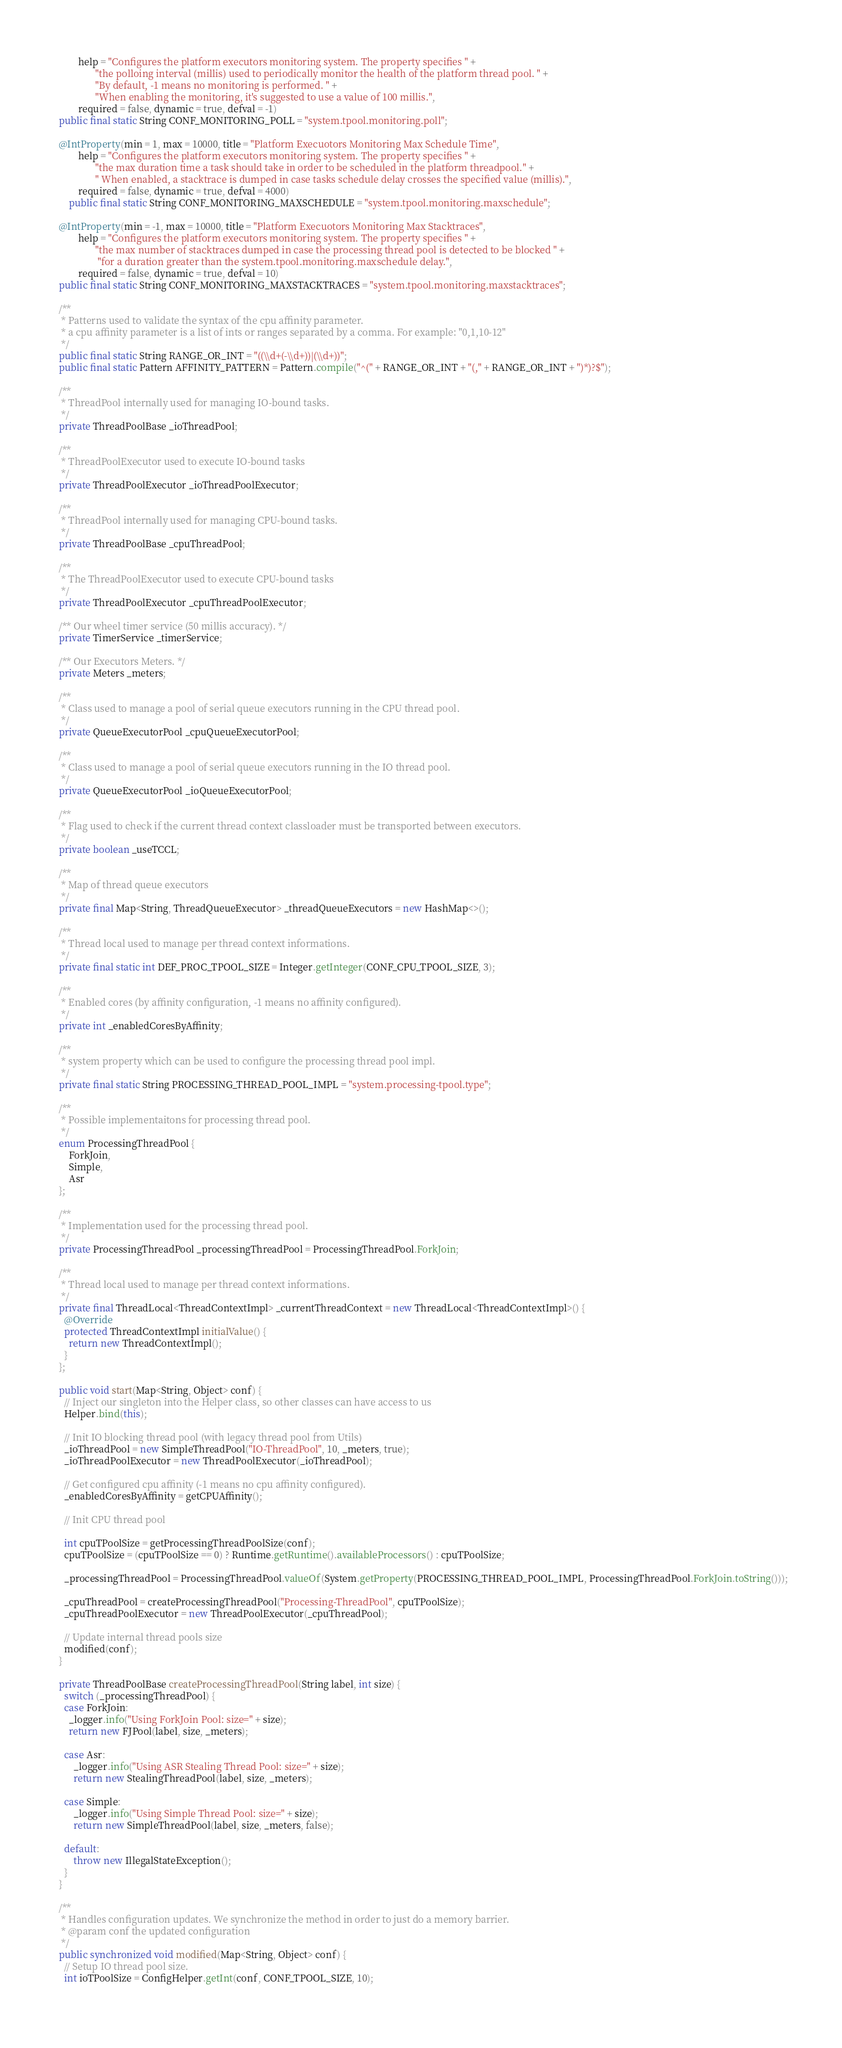Convert code to text. <code><loc_0><loc_0><loc_500><loc_500><_Java_>	      help = "Configures the platform executors monitoring system. The property specifies " +
	             "the polloing interval (millis) used to periodically monitor the health of the platform thread pool. " +
	    		 "By default, -1 means no monitoring is performed. " +
	             "When enabling the monitoring, it's suggested to use a value of 100 millis.",
	      required = false, dynamic = true, defval = -1)
  public final static String CONF_MONITORING_POLL = "system.tpool.monitoring.poll";

  @IntProperty(min = 1, max = 10000, title = "Platform Execuotors Monitoring Max Schedule Time",
	      help = "Configures the platform executors monitoring system. The property specifies " +
	             "the max duration time a task should take in order to be scheduled in the platform threadpool." +
	    		 " When enabled, a stacktrace is dumped in case tasks schedule delay crosses the specified value (millis).",
	      required = false, dynamic = true, defval = 4000)
	  public final static String CONF_MONITORING_MAXSCHEDULE = "system.tpool.monitoring.maxschedule";

  @IntProperty(min = -1, max = 10000, title = "Platform Execuotors Monitoring Max Stacktraces",
	      help = "Configures the platform executors monitoring system. The property specifies " +
	             "the max number of stacktraces dumped in case the processing thread pool is detected to be blocked " +
	    		  "for a duration greater than the system.tpool.monitoring.maxschedule delay.",
	      required = false, dynamic = true, defval = 10)
  public final static String CONF_MONITORING_MAXSTACKTRACES = "system.tpool.monitoring.maxstacktraces";

  /** 
   * Patterns used to validate the syntax of the cpu affinity parameter. 
   * a cpu affinity parameter is a list of ints or ranges separated by a comma. For example: "0,1,10-12"
   */
  public final static String RANGE_OR_INT = "((\\d+(-\\d+))|(\\d+))";
  public final static Pattern AFFINITY_PATTERN = Pattern.compile("^(" + RANGE_OR_INT + "(," + RANGE_OR_INT + ")*)?$");

  /** 
   * ThreadPool internally used for managing IO-bound tasks.
   */
  private ThreadPoolBase _ioThreadPool;
  
  /** 
   * ThreadPoolExecutor used to execute IO-bound tasks 
   */
  private ThreadPoolExecutor _ioThreadPoolExecutor;
  
  /** 
   * ThreadPool internally used for managing CPU-bound tasks.
   */
  private ThreadPoolBase _cpuThreadPool;
  
  /** 
   * The ThreadPoolExecutor used to execute CPU-bound tasks 
   */
  private ThreadPoolExecutor _cpuThreadPoolExecutor;
  
  /** Our wheel timer service (50 millis accuracy). */
  private TimerService _timerService;
    
  /** Our Executors Meters. */
  private Meters _meters;

  /** 
   * Class used to manage a pool of serial queue executors running in the CPU thread pool. 
   */
  private QueueExecutorPool _cpuQueueExecutorPool;
  
  /** 
   * Class used to manage a pool of serial queue executors running in the IO thread pool. 
   */
  private QueueExecutorPool _ioQueueExecutorPool;
  
  /** 
   * Flag used to check if the current thread context classloader must be transported between executors. 
   */
  private boolean _useTCCL;
  
  /** 
   * Map of thread queue executors 
   */
  private final Map<String, ThreadQueueExecutor> _threadQueueExecutors = new HashMap<>();
  
  /**
   * Thread local used to manage per thread context informations.
   */
  private final static int DEF_PROC_TPOOL_SIZE = Integer.getInteger(CONF_CPU_TPOOL_SIZE, 3);
  
  /**
   * Enabled cores (by affinity configuration, -1 means no affinity configured).
   */
  private int _enabledCoresByAffinity;
  
  /**
   * system property which can be used to configure the processing thread pool impl.
   */
  private final static String PROCESSING_THREAD_POOL_IMPL = "system.processing-tpool.type";
  
  /**
   * Possible implementaitons for processing thread pool.
   */
  enum ProcessingThreadPool {
	  ForkJoin,
	  Simple,
	  Asr
  };
  
  /**
   * Implementation used for the processing thread pool.
   */
  private ProcessingThreadPool _processingThreadPool = ProcessingThreadPool.ForkJoin;

  /** 
   * Thread local used to manage per thread context informations.
   */
  private final ThreadLocal<ThreadContextImpl> _currentThreadContext = new ThreadLocal<ThreadContextImpl>() {
    @Override
    protected ThreadContextImpl initialValue() {
      return new ThreadContextImpl();
    }
  };
  
  public void start(Map<String, Object> conf) {
    // Inject our singleton into the Helper class, so other classes can have access to us
    Helper.bind(this);
    
    // Init IO blocking thread pool (with legacy thread pool from Utils)
    _ioThreadPool = new SimpleThreadPool("IO-ThreadPool", 10, _meters, true);
    _ioThreadPoolExecutor = new ThreadPoolExecutor(_ioThreadPool);
    
    // Get configured cpu affinity (-1 means no cpu affinity configured).
    _enabledCoresByAffinity = getCPUAffinity();
    
    // Init CPU thread pool
    
    int cpuTPoolSize = getProcessingThreadPoolSize(conf);
    cpuTPoolSize = (cpuTPoolSize == 0) ? Runtime.getRuntime().availableProcessors() : cpuTPoolSize;
    
    _processingThreadPool = ProcessingThreadPool.valueOf(System.getProperty(PROCESSING_THREAD_POOL_IMPL, ProcessingThreadPool.ForkJoin.toString()));
    
    _cpuThreadPool = createProcessingThreadPool("Processing-ThreadPool", cpuTPoolSize);
    _cpuThreadPoolExecutor = new ThreadPoolExecutor(_cpuThreadPool);

    // Update internal thread pools size
    modified(conf);
  }
  
  private ThreadPoolBase createProcessingThreadPool(String label, int size) {
	switch (_processingThreadPool) {
	case ForkJoin:
      _logger.info("Using ForkJoin Pool: size=" + size);
      return new FJPool(label, size, _meters);
      
	case Asr:		
		_logger.info("Using ASR Stealing Thread Pool: size=" + size);
		return new StealingThreadPool(label, size, _meters);
		
	case Simple:
		_logger.info("Using Simple Thread Pool: size=" + size);
		return new SimpleThreadPool(label, size, _meters, false);
		
	default:
		throw new IllegalStateException();
	}
  }
  
  /**
   * Handles configuration updates. We synchronize the method in order to just do a memory barrier.
   * @param conf the updated configuration
   */
  public synchronized void modified(Map<String, Object> conf) {    
    // Setup IO thread pool size.
    int ioTPoolSize = ConfigHelper.getInt(conf, CONF_TPOOL_SIZE, 10);
    </code> 